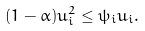<formula> <loc_0><loc_0><loc_500><loc_500>( 1 - \alpha ) u _ { i } ^ { 2 } \leq \psi _ { i } u _ { i } .</formula> 